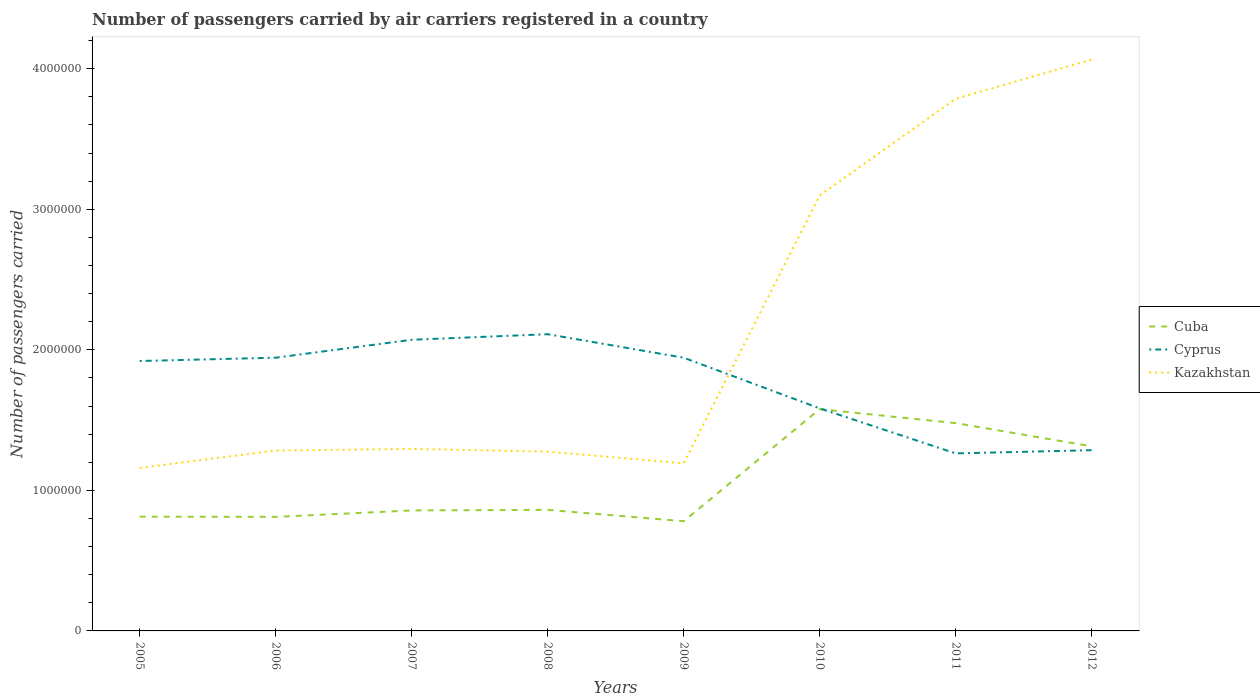How many different coloured lines are there?
Give a very brief answer. 3. Is the number of lines equal to the number of legend labels?
Make the answer very short. Yes. Across all years, what is the maximum number of passengers carried by air carriers in Cyprus?
Your answer should be very brief. 1.26e+06. What is the total number of passengers carried by air carriers in Kazakhstan in the graph?
Provide a short and direct response. -2.78e+05. What is the difference between the highest and the second highest number of passengers carried by air carriers in Kazakhstan?
Your answer should be very brief. 2.90e+06. What is the difference between the highest and the lowest number of passengers carried by air carriers in Cyprus?
Give a very brief answer. 5. Is the number of passengers carried by air carriers in Cuba strictly greater than the number of passengers carried by air carriers in Cyprus over the years?
Keep it short and to the point. No. How many lines are there?
Offer a very short reply. 3. Does the graph contain any zero values?
Offer a very short reply. No. Does the graph contain grids?
Provide a succinct answer. No. How are the legend labels stacked?
Your answer should be compact. Vertical. What is the title of the graph?
Offer a terse response. Number of passengers carried by air carriers registered in a country. Does "Greece" appear as one of the legend labels in the graph?
Your answer should be compact. No. What is the label or title of the X-axis?
Provide a short and direct response. Years. What is the label or title of the Y-axis?
Provide a succinct answer. Number of passengers carried. What is the Number of passengers carried of Cuba in 2005?
Keep it short and to the point. 8.13e+05. What is the Number of passengers carried of Cyprus in 2005?
Provide a succinct answer. 1.92e+06. What is the Number of passengers carried of Kazakhstan in 2005?
Make the answer very short. 1.16e+06. What is the Number of passengers carried of Cuba in 2006?
Offer a terse response. 8.12e+05. What is the Number of passengers carried of Cyprus in 2006?
Provide a succinct answer. 1.94e+06. What is the Number of passengers carried of Kazakhstan in 2006?
Ensure brevity in your answer.  1.28e+06. What is the Number of passengers carried in Cuba in 2007?
Ensure brevity in your answer.  8.57e+05. What is the Number of passengers carried in Cyprus in 2007?
Offer a very short reply. 2.07e+06. What is the Number of passengers carried of Kazakhstan in 2007?
Your response must be concise. 1.30e+06. What is the Number of passengers carried in Cuba in 2008?
Give a very brief answer. 8.61e+05. What is the Number of passengers carried in Cyprus in 2008?
Provide a short and direct response. 2.11e+06. What is the Number of passengers carried in Kazakhstan in 2008?
Your answer should be compact. 1.28e+06. What is the Number of passengers carried of Cuba in 2009?
Offer a very short reply. 7.80e+05. What is the Number of passengers carried in Cyprus in 2009?
Give a very brief answer. 1.94e+06. What is the Number of passengers carried of Kazakhstan in 2009?
Keep it short and to the point. 1.19e+06. What is the Number of passengers carried of Cuba in 2010?
Your answer should be very brief. 1.58e+06. What is the Number of passengers carried of Cyprus in 2010?
Offer a very short reply. 1.58e+06. What is the Number of passengers carried of Kazakhstan in 2010?
Make the answer very short. 3.10e+06. What is the Number of passengers carried of Cuba in 2011?
Make the answer very short. 1.48e+06. What is the Number of passengers carried of Cyprus in 2011?
Ensure brevity in your answer.  1.26e+06. What is the Number of passengers carried of Kazakhstan in 2011?
Make the answer very short. 3.79e+06. What is the Number of passengers carried of Cuba in 2012?
Your answer should be very brief. 1.31e+06. What is the Number of passengers carried in Cyprus in 2012?
Make the answer very short. 1.29e+06. What is the Number of passengers carried in Kazakhstan in 2012?
Your response must be concise. 4.06e+06. Across all years, what is the maximum Number of passengers carried in Cuba?
Give a very brief answer. 1.58e+06. Across all years, what is the maximum Number of passengers carried in Cyprus?
Keep it short and to the point. 2.11e+06. Across all years, what is the maximum Number of passengers carried in Kazakhstan?
Provide a short and direct response. 4.06e+06. Across all years, what is the minimum Number of passengers carried of Cuba?
Offer a terse response. 7.80e+05. Across all years, what is the minimum Number of passengers carried in Cyprus?
Offer a terse response. 1.26e+06. Across all years, what is the minimum Number of passengers carried in Kazakhstan?
Your answer should be compact. 1.16e+06. What is the total Number of passengers carried of Cuba in the graph?
Ensure brevity in your answer.  8.49e+06. What is the total Number of passengers carried in Cyprus in the graph?
Provide a short and direct response. 1.41e+07. What is the total Number of passengers carried in Kazakhstan in the graph?
Give a very brief answer. 1.72e+07. What is the difference between the Number of passengers carried of Cuba in 2005 and that in 2006?
Offer a terse response. 1222. What is the difference between the Number of passengers carried of Cyprus in 2005 and that in 2006?
Your response must be concise. -2.36e+04. What is the difference between the Number of passengers carried in Kazakhstan in 2005 and that in 2006?
Give a very brief answer. -1.23e+05. What is the difference between the Number of passengers carried of Cuba in 2005 and that in 2007?
Your response must be concise. -4.44e+04. What is the difference between the Number of passengers carried of Cyprus in 2005 and that in 2007?
Provide a succinct answer. -1.51e+05. What is the difference between the Number of passengers carried of Kazakhstan in 2005 and that in 2007?
Offer a terse response. -1.35e+05. What is the difference between the Number of passengers carried of Cuba in 2005 and that in 2008?
Provide a succinct answer. -4.86e+04. What is the difference between the Number of passengers carried in Cyprus in 2005 and that in 2008?
Your answer should be very brief. -1.91e+05. What is the difference between the Number of passengers carried in Kazakhstan in 2005 and that in 2008?
Give a very brief answer. -1.15e+05. What is the difference between the Number of passengers carried in Cuba in 2005 and that in 2009?
Make the answer very short. 3.23e+04. What is the difference between the Number of passengers carried in Cyprus in 2005 and that in 2009?
Provide a short and direct response. -2.34e+04. What is the difference between the Number of passengers carried in Kazakhstan in 2005 and that in 2009?
Provide a short and direct response. -3.24e+04. What is the difference between the Number of passengers carried of Cuba in 2005 and that in 2010?
Offer a terse response. -7.65e+05. What is the difference between the Number of passengers carried of Cyprus in 2005 and that in 2010?
Your answer should be very brief. 3.37e+05. What is the difference between the Number of passengers carried in Kazakhstan in 2005 and that in 2010?
Your response must be concise. -1.94e+06. What is the difference between the Number of passengers carried in Cuba in 2005 and that in 2011?
Give a very brief answer. -6.66e+05. What is the difference between the Number of passengers carried in Cyprus in 2005 and that in 2011?
Your response must be concise. 6.57e+05. What is the difference between the Number of passengers carried in Kazakhstan in 2005 and that in 2011?
Your answer should be compact. -2.63e+06. What is the difference between the Number of passengers carried in Cuba in 2005 and that in 2012?
Your response must be concise. -5.01e+05. What is the difference between the Number of passengers carried in Cyprus in 2005 and that in 2012?
Your answer should be very brief. 6.35e+05. What is the difference between the Number of passengers carried of Kazakhstan in 2005 and that in 2012?
Make the answer very short. -2.90e+06. What is the difference between the Number of passengers carried in Cuba in 2006 and that in 2007?
Give a very brief answer. -4.57e+04. What is the difference between the Number of passengers carried in Cyprus in 2006 and that in 2007?
Ensure brevity in your answer.  -1.28e+05. What is the difference between the Number of passengers carried in Kazakhstan in 2006 and that in 2007?
Make the answer very short. -1.18e+04. What is the difference between the Number of passengers carried in Cuba in 2006 and that in 2008?
Your answer should be compact. -4.98e+04. What is the difference between the Number of passengers carried of Cyprus in 2006 and that in 2008?
Keep it short and to the point. -1.67e+05. What is the difference between the Number of passengers carried in Kazakhstan in 2006 and that in 2008?
Provide a succinct answer. 7626. What is the difference between the Number of passengers carried of Cuba in 2006 and that in 2009?
Make the answer very short. 3.11e+04. What is the difference between the Number of passengers carried in Cyprus in 2006 and that in 2009?
Your answer should be compact. 189. What is the difference between the Number of passengers carried of Kazakhstan in 2006 and that in 2009?
Your answer should be compact. 9.05e+04. What is the difference between the Number of passengers carried in Cuba in 2006 and that in 2010?
Make the answer very short. -7.66e+05. What is the difference between the Number of passengers carried in Cyprus in 2006 and that in 2010?
Offer a terse response. 3.61e+05. What is the difference between the Number of passengers carried of Kazakhstan in 2006 and that in 2010?
Provide a succinct answer. -1.82e+06. What is the difference between the Number of passengers carried of Cuba in 2006 and that in 2011?
Keep it short and to the point. -6.67e+05. What is the difference between the Number of passengers carried in Cyprus in 2006 and that in 2011?
Your answer should be very brief. 6.81e+05. What is the difference between the Number of passengers carried of Kazakhstan in 2006 and that in 2011?
Keep it short and to the point. -2.50e+06. What is the difference between the Number of passengers carried of Cuba in 2006 and that in 2012?
Offer a very short reply. -5.02e+05. What is the difference between the Number of passengers carried in Cyprus in 2006 and that in 2012?
Your answer should be compact. 6.58e+05. What is the difference between the Number of passengers carried in Kazakhstan in 2006 and that in 2012?
Ensure brevity in your answer.  -2.78e+06. What is the difference between the Number of passengers carried in Cuba in 2007 and that in 2008?
Keep it short and to the point. -4139. What is the difference between the Number of passengers carried of Cyprus in 2007 and that in 2008?
Give a very brief answer. -3.96e+04. What is the difference between the Number of passengers carried in Kazakhstan in 2007 and that in 2008?
Offer a terse response. 1.94e+04. What is the difference between the Number of passengers carried in Cuba in 2007 and that in 2009?
Your answer should be very brief. 7.67e+04. What is the difference between the Number of passengers carried in Cyprus in 2007 and that in 2009?
Make the answer very short. 1.28e+05. What is the difference between the Number of passengers carried in Kazakhstan in 2007 and that in 2009?
Give a very brief answer. 1.02e+05. What is the difference between the Number of passengers carried in Cuba in 2007 and that in 2010?
Provide a succinct answer. -7.21e+05. What is the difference between the Number of passengers carried of Cyprus in 2007 and that in 2010?
Keep it short and to the point. 4.88e+05. What is the difference between the Number of passengers carried in Kazakhstan in 2007 and that in 2010?
Offer a terse response. -1.80e+06. What is the difference between the Number of passengers carried in Cuba in 2007 and that in 2011?
Provide a short and direct response. -6.21e+05. What is the difference between the Number of passengers carried of Cyprus in 2007 and that in 2011?
Provide a short and direct response. 8.09e+05. What is the difference between the Number of passengers carried in Kazakhstan in 2007 and that in 2011?
Your answer should be compact. -2.49e+06. What is the difference between the Number of passengers carried in Cuba in 2007 and that in 2012?
Your response must be concise. -4.56e+05. What is the difference between the Number of passengers carried in Cyprus in 2007 and that in 2012?
Give a very brief answer. 7.86e+05. What is the difference between the Number of passengers carried of Kazakhstan in 2007 and that in 2012?
Your response must be concise. -2.77e+06. What is the difference between the Number of passengers carried of Cuba in 2008 and that in 2009?
Give a very brief answer. 8.09e+04. What is the difference between the Number of passengers carried of Cyprus in 2008 and that in 2009?
Your answer should be compact. 1.67e+05. What is the difference between the Number of passengers carried of Kazakhstan in 2008 and that in 2009?
Provide a short and direct response. 8.29e+04. What is the difference between the Number of passengers carried of Cuba in 2008 and that in 2010?
Make the answer very short. -7.17e+05. What is the difference between the Number of passengers carried of Cyprus in 2008 and that in 2010?
Your answer should be very brief. 5.28e+05. What is the difference between the Number of passengers carried of Kazakhstan in 2008 and that in 2010?
Keep it short and to the point. -1.82e+06. What is the difference between the Number of passengers carried in Cuba in 2008 and that in 2011?
Keep it short and to the point. -6.17e+05. What is the difference between the Number of passengers carried in Cyprus in 2008 and that in 2011?
Provide a short and direct response. 8.48e+05. What is the difference between the Number of passengers carried of Kazakhstan in 2008 and that in 2011?
Your answer should be very brief. -2.51e+06. What is the difference between the Number of passengers carried of Cuba in 2008 and that in 2012?
Offer a very short reply. -4.52e+05. What is the difference between the Number of passengers carried in Cyprus in 2008 and that in 2012?
Make the answer very short. 8.25e+05. What is the difference between the Number of passengers carried in Kazakhstan in 2008 and that in 2012?
Give a very brief answer. -2.79e+06. What is the difference between the Number of passengers carried of Cuba in 2009 and that in 2010?
Your response must be concise. -7.98e+05. What is the difference between the Number of passengers carried in Cyprus in 2009 and that in 2010?
Your answer should be very brief. 3.60e+05. What is the difference between the Number of passengers carried of Kazakhstan in 2009 and that in 2010?
Keep it short and to the point. -1.91e+06. What is the difference between the Number of passengers carried in Cuba in 2009 and that in 2011?
Your answer should be very brief. -6.98e+05. What is the difference between the Number of passengers carried of Cyprus in 2009 and that in 2011?
Your answer should be compact. 6.81e+05. What is the difference between the Number of passengers carried in Kazakhstan in 2009 and that in 2011?
Provide a succinct answer. -2.59e+06. What is the difference between the Number of passengers carried of Cuba in 2009 and that in 2012?
Ensure brevity in your answer.  -5.33e+05. What is the difference between the Number of passengers carried of Cyprus in 2009 and that in 2012?
Make the answer very short. 6.58e+05. What is the difference between the Number of passengers carried in Kazakhstan in 2009 and that in 2012?
Offer a very short reply. -2.87e+06. What is the difference between the Number of passengers carried of Cuba in 2010 and that in 2011?
Make the answer very short. 9.94e+04. What is the difference between the Number of passengers carried in Cyprus in 2010 and that in 2011?
Offer a very short reply. 3.21e+05. What is the difference between the Number of passengers carried in Kazakhstan in 2010 and that in 2011?
Your answer should be very brief. -6.88e+05. What is the difference between the Number of passengers carried in Cuba in 2010 and that in 2012?
Make the answer very short. 2.65e+05. What is the difference between the Number of passengers carried in Cyprus in 2010 and that in 2012?
Provide a succinct answer. 2.98e+05. What is the difference between the Number of passengers carried in Kazakhstan in 2010 and that in 2012?
Make the answer very short. -9.66e+05. What is the difference between the Number of passengers carried in Cuba in 2011 and that in 2012?
Provide a short and direct response. 1.65e+05. What is the difference between the Number of passengers carried of Cyprus in 2011 and that in 2012?
Offer a terse response. -2.29e+04. What is the difference between the Number of passengers carried of Kazakhstan in 2011 and that in 2012?
Ensure brevity in your answer.  -2.78e+05. What is the difference between the Number of passengers carried in Cuba in 2005 and the Number of passengers carried in Cyprus in 2006?
Your answer should be compact. -1.13e+06. What is the difference between the Number of passengers carried in Cuba in 2005 and the Number of passengers carried in Kazakhstan in 2006?
Provide a short and direct response. -4.70e+05. What is the difference between the Number of passengers carried of Cyprus in 2005 and the Number of passengers carried of Kazakhstan in 2006?
Your answer should be very brief. 6.37e+05. What is the difference between the Number of passengers carried in Cuba in 2005 and the Number of passengers carried in Cyprus in 2007?
Your response must be concise. -1.26e+06. What is the difference between the Number of passengers carried of Cuba in 2005 and the Number of passengers carried of Kazakhstan in 2007?
Provide a short and direct response. -4.82e+05. What is the difference between the Number of passengers carried in Cyprus in 2005 and the Number of passengers carried in Kazakhstan in 2007?
Keep it short and to the point. 6.25e+05. What is the difference between the Number of passengers carried in Cuba in 2005 and the Number of passengers carried in Cyprus in 2008?
Keep it short and to the point. -1.30e+06. What is the difference between the Number of passengers carried of Cuba in 2005 and the Number of passengers carried of Kazakhstan in 2008?
Ensure brevity in your answer.  -4.63e+05. What is the difference between the Number of passengers carried of Cyprus in 2005 and the Number of passengers carried of Kazakhstan in 2008?
Provide a short and direct response. 6.45e+05. What is the difference between the Number of passengers carried of Cuba in 2005 and the Number of passengers carried of Cyprus in 2009?
Offer a terse response. -1.13e+06. What is the difference between the Number of passengers carried in Cuba in 2005 and the Number of passengers carried in Kazakhstan in 2009?
Your response must be concise. -3.80e+05. What is the difference between the Number of passengers carried of Cyprus in 2005 and the Number of passengers carried of Kazakhstan in 2009?
Your answer should be very brief. 7.28e+05. What is the difference between the Number of passengers carried of Cuba in 2005 and the Number of passengers carried of Cyprus in 2010?
Offer a terse response. -7.71e+05. What is the difference between the Number of passengers carried in Cuba in 2005 and the Number of passengers carried in Kazakhstan in 2010?
Offer a terse response. -2.29e+06. What is the difference between the Number of passengers carried of Cyprus in 2005 and the Number of passengers carried of Kazakhstan in 2010?
Your answer should be very brief. -1.18e+06. What is the difference between the Number of passengers carried in Cuba in 2005 and the Number of passengers carried in Cyprus in 2011?
Provide a succinct answer. -4.50e+05. What is the difference between the Number of passengers carried in Cuba in 2005 and the Number of passengers carried in Kazakhstan in 2011?
Ensure brevity in your answer.  -2.97e+06. What is the difference between the Number of passengers carried in Cyprus in 2005 and the Number of passengers carried in Kazakhstan in 2011?
Offer a terse response. -1.87e+06. What is the difference between the Number of passengers carried in Cuba in 2005 and the Number of passengers carried in Cyprus in 2012?
Make the answer very short. -4.73e+05. What is the difference between the Number of passengers carried of Cuba in 2005 and the Number of passengers carried of Kazakhstan in 2012?
Provide a succinct answer. -3.25e+06. What is the difference between the Number of passengers carried of Cyprus in 2005 and the Number of passengers carried of Kazakhstan in 2012?
Your response must be concise. -2.14e+06. What is the difference between the Number of passengers carried in Cuba in 2006 and the Number of passengers carried in Cyprus in 2007?
Keep it short and to the point. -1.26e+06. What is the difference between the Number of passengers carried of Cuba in 2006 and the Number of passengers carried of Kazakhstan in 2007?
Your answer should be compact. -4.83e+05. What is the difference between the Number of passengers carried in Cyprus in 2006 and the Number of passengers carried in Kazakhstan in 2007?
Give a very brief answer. 6.49e+05. What is the difference between the Number of passengers carried in Cuba in 2006 and the Number of passengers carried in Cyprus in 2008?
Your answer should be very brief. -1.30e+06. What is the difference between the Number of passengers carried of Cuba in 2006 and the Number of passengers carried of Kazakhstan in 2008?
Keep it short and to the point. -4.64e+05. What is the difference between the Number of passengers carried of Cyprus in 2006 and the Number of passengers carried of Kazakhstan in 2008?
Your answer should be very brief. 6.69e+05. What is the difference between the Number of passengers carried in Cuba in 2006 and the Number of passengers carried in Cyprus in 2009?
Make the answer very short. -1.13e+06. What is the difference between the Number of passengers carried in Cuba in 2006 and the Number of passengers carried in Kazakhstan in 2009?
Your answer should be very brief. -3.81e+05. What is the difference between the Number of passengers carried of Cyprus in 2006 and the Number of passengers carried of Kazakhstan in 2009?
Your answer should be compact. 7.51e+05. What is the difference between the Number of passengers carried in Cuba in 2006 and the Number of passengers carried in Cyprus in 2010?
Provide a succinct answer. -7.72e+05. What is the difference between the Number of passengers carried of Cuba in 2006 and the Number of passengers carried of Kazakhstan in 2010?
Offer a terse response. -2.29e+06. What is the difference between the Number of passengers carried of Cyprus in 2006 and the Number of passengers carried of Kazakhstan in 2010?
Keep it short and to the point. -1.15e+06. What is the difference between the Number of passengers carried in Cuba in 2006 and the Number of passengers carried in Cyprus in 2011?
Provide a succinct answer. -4.52e+05. What is the difference between the Number of passengers carried of Cuba in 2006 and the Number of passengers carried of Kazakhstan in 2011?
Give a very brief answer. -2.97e+06. What is the difference between the Number of passengers carried of Cyprus in 2006 and the Number of passengers carried of Kazakhstan in 2011?
Give a very brief answer. -1.84e+06. What is the difference between the Number of passengers carried of Cuba in 2006 and the Number of passengers carried of Cyprus in 2012?
Ensure brevity in your answer.  -4.74e+05. What is the difference between the Number of passengers carried of Cuba in 2006 and the Number of passengers carried of Kazakhstan in 2012?
Offer a terse response. -3.25e+06. What is the difference between the Number of passengers carried in Cyprus in 2006 and the Number of passengers carried in Kazakhstan in 2012?
Give a very brief answer. -2.12e+06. What is the difference between the Number of passengers carried of Cuba in 2007 and the Number of passengers carried of Cyprus in 2008?
Offer a very short reply. -1.25e+06. What is the difference between the Number of passengers carried in Cuba in 2007 and the Number of passengers carried in Kazakhstan in 2008?
Your answer should be very brief. -4.18e+05. What is the difference between the Number of passengers carried in Cyprus in 2007 and the Number of passengers carried in Kazakhstan in 2008?
Make the answer very short. 7.96e+05. What is the difference between the Number of passengers carried of Cuba in 2007 and the Number of passengers carried of Cyprus in 2009?
Your answer should be compact. -1.09e+06. What is the difference between the Number of passengers carried in Cuba in 2007 and the Number of passengers carried in Kazakhstan in 2009?
Your response must be concise. -3.36e+05. What is the difference between the Number of passengers carried of Cyprus in 2007 and the Number of passengers carried of Kazakhstan in 2009?
Make the answer very short. 8.79e+05. What is the difference between the Number of passengers carried in Cuba in 2007 and the Number of passengers carried in Cyprus in 2010?
Your response must be concise. -7.26e+05. What is the difference between the Number of passengers carried of Cuba in 2007 and the Number of passengers carried of Kazakhstan in 2010?
Provide a short and direct response. -2.24e+06. What is the difference between the Number of passengers carried of Cyprus in 2007 and the Number of passengers carried of Kazakhstan in 2010?
Give a very brief answer. -1.03e+06. What is the difference between the Number of passengers carried of Cuba in 2007 and the Number of passengers carried of Cyprus in 2011?
Give a very brief answer. -4.06e+05. What is the difference between the Number of passengers carried in Cuba in 2007 and the Number of passengers carried in Kazakhstan in 2011?
Provide a short and direct response. -2.93e+06. What is the difference between the Number of passengers carried in Cyprus in 2007 and the Number of passengers carried in Kazakhstan in 2011?
Give a very brief answer. -1.71e+06. What is the difference between the Number of passengers carried in Cuba in 2007 and the Number of passengers carried in Cyprus in 2012?
Your answer should be very brief. -4.29e+05. What is the difference between the Number of passengers carried in Cuba in 2007 and the Number of passengers carried in Kazakhstan in 2012?
Provide a succinct answer. -3.21e+06. What is the difference between the Number of passengers carried of Cyprus in 2007 and the Number of passengers carried of Kazakhstan in 2012?
Provide a succinct answer. -1.99e+06. What is the difference between the Number of passengers carried of Cuba in 2008 and the Number of passengers carried of Cyprus in 2009?
Offer a terse response. -1.08e+06. What is the difference between the Number of passengers carried of Cuba in 2008 and the Number of passengers carried of Kazakhstan in 2009?
Your answer should be very brief. -3.31e+05. What is the difference between the Number of passengers carried of Cyprus in 2008 and the Number of passengers carried of Kazakhstan in 2009?
Your answer should be compact. 9.18e+05. What is the difference between the Number of passengers carried of Cuba in 2008 and the Number of passengers carried of Cyprus in 2010?
Your answer should be very brief. -7.22e+05. What is the difference between the Number of passengers carried of Cuba in 2008 and the Number of passengers carried of Kazakhstan in 2010?
Your response must be concise. -2.24e+06. What is the difference between the Number of passengers carried in Cyprus in 2008 and the Number of passengers carried in Kazakhstan in 2010?
Keep it short and to the point. -9.87e+05. What is the difference between the Number of passengers carried of Cuba in 2008 and the Number of passengers carried of Cyprus in 2011?
Make the answer very short. -4.02e+05. What is the difference between the Number of passengers carried in Cuba in 2008 and the Number of passengers carried in Kazakhstan in 2011?
Make the answer very short. -2.93e+06. What is the difference between the Number of passengers carried of Cyprus in 2008 and the Number of passengers carried of Kazakhstan in 2011?
Your answer should be compact. -1.68e+06. What is the difference between the Number of passengers carried of Cuba in 2008 and the Number of passengers carried of Cyprus in 2012?
Your answer should be very brief. -4.25e+05. What is the difference between the Number of passengers carried in Cuba in 2008 and the Number of passengers carried in Kazakhstan in 2012?
Your response must be concise. -3.20e+06. What is the difference between the Number of passengers carried of Cyprus in 2008 and the Number of passengers carried of Kazakhstan in 2012?
Provide a short and direct response. -1.95e+06. What is the difference between the Number of passengers carried of Cuba in 2009 and the Number of passengers carried of Cyprus in 2010?
Your response must be concise. -8.03e+05. What is the difference between the Number of passengers carried in Cuba in 2009 and the Number of passengers carried in Kazakhstan in 2010?
Ensure brevity in your answer.  -2.32e+06. What is the difference between the Number of passengers carried in Cyprus in 2009 and the Number of passengers carried in Kazakhstan in 2010?
Provide a succinct answer. -1.15e+06. What is the difference between the Number of passengers carried of Cuba in 2009 and the Number of passengers carried of Cyprus in 2011?
Make the answer very short. -4.83e+05. What is the difference between the Number of passengers carried in Cuba in 2009 and the Number of passengers carried in Kazakhstan in 2011?
Offer a very short reply. -3.01e+06. What is the difference between the Number of passengers carried of Cyprus in 2009 and the Number of passengers carried of Kazakhstan in 2011?
Give a very brief answer. -1.84e+06. What is the difference between the Number of passengers carried of Cuba in 2009 and the Number of passengers carried of Cyprus in 2012?
Your answer should be very brief. -5.05e+05. What is the difference between the Number of passengers carried of Cuba in 2009 and the Number of passengers carried of Kazakhstan in 2012?
Your answer should be compact. -3.28e+06. What is the difference between the Number of passengers carried of Cyprus in 2009 and the Number of passengers carried of Kazakhstan in 2012?
Give a very brief answer. -2.12e+06. What is the difference between the Number of passengers carried in Cuba in 2010 and the Number of passengers carried in Cyprus in 2011?
Make the answer very short. 3.15e+05. What is the difference between the Number of passengers carried of Cuba in 2010 and the Number of passengers carried of Kazakhstan in 2011?
Provide a short and direct response. -2.21e+06. What is the difference between the Number of passengers carried in Cyprus in 2010 and the Number of passengers carried in Kazakhstan in 2011?
Provide a short and direct response. -2.20e+06. What is the difference between the Number of passengers carried of Cuba in 2010 and the Number of passengers carried of Cyprus in 2012?
Offer a terse response. 2.92e+05. What is the difference between the Number of passengers carried of Cuba in 2010 and the Number of passengers carried of Kazakhstan in 2012?
Your response must be concise. -2.49e+06. What is the difference between the Number of passengers carried of Cyprus in 2010 and the Number of passengers carried of Kazakhstan in 2012?
Offer a very short reply. -2.48e+06. What is the difference between the Number of passengers carried in Cuba in 2011 and the Number of passengers carried in Cyprus in 2012?
Keep it short and to the point. 1.93e+05. What is the difference between the Number of passengers carried of Cuba in 2011 and the Number of passengers carried of Kazakhstan in 2012?
Provide a short and direct response. -2.59e+06. What is the difference between the Number of passengers carried in Cyprus in 2011 and the Number of passengers carried in Kazakhstan in 2012?
Offer a very short reply. -2.80e+06. What is the average Number of passengers carried of Cuba per year?
Offer a very short reply. 1.06e+06. What is the average Number of passengers carried in Cyprus per year?
Offer a very short reply. 1.77e+06. What is the average Number of passengers carried of Kazakhstan per year?
Your answer should be compact. 2.14e+06. In the year 2005, what is the difference between the Number of passengers carried of Cuba and Number of passengers carried of Cyprus?
Your answer should be very brief. -1.11e+06. In the year 2005, what is the difference between the Number of passengers carried in Cuba and Number of passengers carried in Kazakhstan?
Keep it short and to the point. -3.48e+05. In the year 2005, what is the difference between the Number of passengers carried of Cyprus and Number of passengers carried of Kazakhstan?
Ensure brevity in your answer.  7.60e+05. In the year 2006, what is the difference between the Number of passengers carried of Cuba and Number of passengers carried of Cyprus?
Make the answer very short. -1.13e+06. In the year 2006, what is the difference between the Number of passengers carried in Cuba and Number of passengers carried in Kazakhstan?
Provide a short and direct response. -4.72e+05. In the year 2006, what is the difference between the Number of passengers carried in Cyprus and Number of passengers carried in Kazakhstan?
Offer a terse response. 6.61e+05. In the year 2007, what is the difference between the Number of passengers carried of Cuba and Number of passengers carried of Cyprus?
Your response must be concise. -1.21e+06. In the year 2007, what is the difference between the Number of passengers carried in Cuba and Number of passengers carried in Kazakhstan?
Make the answer very short. -4.38e+05. In the year 2007, what is the difference between the Number of passengers carried of Cyprus and Number of passengers carried of Kazakhstan?
Give a very brief answer. 7.77e+05. In the year 2008, what is the difference between the Number of passengers carried of Cuba and Number of passengers carried of Cyprus?
Ensure brevity in your answer.  -1.25e+06. In the year 2008, what is the difference between the Number of passengers carried in Cuba and Number of passengers carried in Kazakhstan?
Your answer should be compact. -4.14e+05. In the year 2008, what is the difference between the Number of passengers carried in Cyprus and Number of passengers carried in Kazakhstan?
Give a very brief answer. 8.36e+05. In the year 2009, what is the difference between the Number of passengers carried in Cuba and Number of passengers carried in Cyprus?
Provide a short and direct response. -1.16e+06. In the year 2009, what is the difference between the Number of passengers carried of Cuba and Number of passengers carried of Kazakhstan?
Offer a terse response. -4.12e+05. In the year 2009, what is the difference between the Number of passengers carried of Cyprus and Number of passengers carried of Kazakhstan?
Your answer should be compact. 7.51e+05. In the year 2010, what is the difference between the Number of passengers carried in Cuba and Number of passengers carried in Cyprus?
Give a very brief answer. -5615.21. In the year 2010, what is the difference between the Number of passengers carried in Cuba and Number of passengers carried in Kazakhstan?
Your response must be concise. -1.52e+06. In the year 2010, what is the difference between the Number of passengers carried of Cyprus and Number of passengers carried of Kazakhstan?
Give a very brief answer. -1.51e+06. In the year 2011, what is the difference between the Number of passengers carried in Cuba and Number of passengers carried in Cyprus?
Ensure brevity in your answer.  2.15e+05. In the year 2011, what is the difference between the Number of passengers carried of Cuba and Number of passengers carried of Kazakhstan?
Provide a short and direct response. -2.31e+06. In the year 2011, what is the difference between the Number of passengers carried of Cyprus and Number of passengers carried of Kazakhstan?
Provide a short and direct response. -2.52e+06. In the year 2012, what is the difference between the Number of passengers carried in Cuba and Number of passengers carried in Cyprus?
Give a very brief answer. 2.75e+04. In the year 2012, what is the difference between the Number of passengers carried in Cuba and Number of passengers carried in Kazakhstan?
Ensure brevity in your answer.  -2.75e+06. In the year 2012, what is the difference between the Number of passengers carried of Cyprus and Number of passengers carried of Kazakhstan?
Your answer should be very brief. -2.78e+06. What is the ratio of the Number of passengers carried in Cuba in 2005 to that in 2006?
Keep it short and to the point. 1. What is the ratio of the Number of passengers carried in Kazakhstan in 2005 to that in 2006?
Ensure brevity in your answer.  0.9. What is the ratio of the Number of passengers carried in Cuba in 2005 to that in 2007?
Keep it short and to the point. 0.95. What is the ratio of the Number of passengers carried in Cyprus in 2005 to that in 2007?
Your answer should be very brief. 0.93. What is the ratio of the Number of passengers carried in Kazakhstan in 2005 to that in 2007?
Make the answer very short. 0.9. What is the ratio of the Number of passengers carried in Cuba in 2005 to that in 2008?
Your answer should be very brief. 0.94. What is the ratio of the Number of passengers carried in Cyprus in 2005 to that in 2008?
Keep it short and to the point. 0.91. What is the ratio of the Number of passengers carried in Kazakhstan in 2005 to that in 2008?
Offer a very short reply. 0.91. What is the ratio of the Number of passengers carried in Cuba in 2005 to that in 2009?
Offer a very short reply. 1.04. What is the ratio of the Number of passengers carried of Cyprus in 2005 to that in 2009?
Provide a succinct answer. 0.99. What is the ratio of the Number of passengers carried in Kazakhstan in 2005 to that in 2009?
Offer a very short reply. 0.97. What is the ratio of the Number of passengers carried in Cuba in 2005 to that in 2010?
Your answer should be compact. 0.52. What is the ratio of the Number of passengers carried of Cyprus in 2005 to that in 2010?
Offer a very short reply. 1.21. What is the ratio of the Number of passengers carried of Kazakhstan in 2005 to that in 2010?
Keep it short and to the point. 0.37. What is the ratio of the Number of passengers carried of Cuba in 2005 to that in 2011?
Your answer should be compact. 0.55. What is the ratio of the Number of passengers carried in Cyprus in 2005 to that in 2011?
Give a very brief answer. 1.52. What is the ratio of the Number of passengers carried of Kazakhstan in 2005 to that in 2011?
Your answer should be compact. 0.31. What is the ratio of the Number of passengers carried of Cuba in 2005 to that in 2012?
Keep it short and to the point. 0.62. What is the ratio of the Number of passengers carried in Cyprus in 2005 to that in 2012?
Make the answer very short. 1.49. What is the ratio of the Number of passengers carried in Kazakhstan in 2005 to that in 2012?
Offer a very short reply. 0.29. What is the ratio of the Number of passengers carried in Cuba in 2006 to that in 2007?
Make the answer very short. 0.95. What is the ratio of the Number of passengers carried in Cyprus in 2006 to that in 2007?
Keep it short and to the point. 0.94. What is the ratio of the Number of passengers carried in Kazakhstan in 2006 to that in 2007?
Give a very brief answer. 0.99. What is the ratio of the Number of passengers carried in Cuba in 2006 to that in 2008?
Keep it short and to the point. 0.94. What is the ratio of the Number of passengers carried in Cyprus in 2006 to that in 2008?
Ensure brevity in your answer.  0.92. What is the ratio of the Number of passengers carried of Kazakhstan in 2006 to that in 2008?
Provide a succinct answer. 1.01. What is the ratio of the Number of passengers carried of Cuba in 2006 to that in 2009?
Keep it short and to the point. 1.04. What is the ratio of the Number of passengers carried in Kazakhstan in 2006 to that in 2009?
Offer a very short reply. 1.08. What is the ratio of the Number of passengers carried in Cuba in 2006 to that in 2010?
Give a very brief answer. 0.51. What is the ratio of the Number of passengers carried of Cyprus in 2006 to that in 2010?
Provide a short and direct response. 1.23. What is the ratio of the Number of passengers carried of Kazakhstan in 2006 to that in 2010?
Your answer should be compact. 0.41. What is the ratio of the Number of passengers carried of Cuba in 2006 to that in 2011?
Keep it short and to the point. 0.55. What is the ratio of the Number of passengers carried of Cyprus in 2006 to that in 2011?
Give a very brief answer. 1.54. What is the ratio of the Number of passengers carried of Kazakhstan in 2006 to that in 2011?
Give a very brief answer. 0.34. What is the ratio of the Number of passengers carried of Cuba in 2006 to that in 2012?
Give a very brief answer. 0.62. What is the ratio of the Number of passengers carried of Cyprus in 2006 to that in 2012?
Provide a short and direct response. 1.51. What is the ratio of the Number of passengers carried of Kazakhstan in 2006 to that in 2012?
Provide a short and direct response. 0.32. What is the ratio of the Number of passengers carried of Cuba in 2007 to that in 2008?
Keep it short and to the point. 1. What is the ratio of the Number of passengers carried of Cyprus in 2007 to that in 2008?
Offer a very short reply. 0.98. What is the ratio of the Number of passengers carried of Kazakhstan in 2007 to that in 2008?
Provide a succinct answer. 1.02. What is the ratio of the Number of passengers carried in Cuba in 2007 to that in 2009?
Keep it short and to the point. 1.1. What is the ratio of the Number of passengers carried of Cyprus in 2007 to that in 2009?
Your answer should be very brief. 1.07. What is the ratio of the Number of passengers carried of Kazakhstan in 2007 to that in 2009?
Provide a short and direct response. 1.09. What is the ratio of the Number of passengers carried in Cuba in 2007 to that in 2010?
Offer a terse response. 0.54. What is the ratio of the Number of passengers carried of Cyprus in 2007 to that in 2010?
Offer a terse response. 1.31. What is the ratio of the Number of passengers carried of Kazakhstan in 2007 to that in 2010?
Provide a succinct answer. 0.42. What is the ratio of the Number of passengers carried in Cuba in 2007 to that in 2011?
Offer a terse response. 0.58. What is the ratio of the Number of passengers carried of Cyprus in 2007 to that in 2011?
Ensure brevity in your answer.  1.64. What is the ratio of the Number of passengers carried of Kazakhstan in 2007 to that in 2011?
Your response must be concise. 0.34. What is the ratio of the Number of passengers carried of Cuba in 2007 to that in 2012?
Offer a terse response. 0.65. What is the ratio of the Number of passengers carried of Cyprus in 2007 to that in 2012?
Your response must be concise. 1.61. What is the ratio of the Number of passengers carried of Kazakhstan in 2007 to that in 2012?
Provide a short and direct response. 0.32. What is the ratio of the Number of passengers carried of Cuba in 2008 to that in 2009?
Your response must be concise. 1.1. What is the ratio of the Number of passengers carried in Cyprus in 2008 to that in 2009?
Your answer should be very brief. 1.09. What is the ratio of the Number of passengers carried of Kazakhstan in 2008 to that in 2009?
Ensure brevity in your answer.  1.07. What is the ratio of the Number of passengers carried in Cuba in 2008 to that in 2010?
Ensure brevity in your answer.  0.55. What is the ratio of the Number of passengers carried of Cyprus in 2008 to that in 2010?
Make the answer very short. 1.33. What is the ratio of the Number of passengers carried in Kazakhstan in 2008 to that in 2010?
Provide a succinct answer. 0.41. What is the ratio of the Number of passengers carried of Cuba in 2008 to that in 2011?
Make the answer very short. 0.58. What is the ratio of the Number of passengers carried of Cyprus in 2008 to that in 2011?
Make the answer very short. 1.67. What is the ratio of the Number of passengers carried in Kazakhstan in 2008 to that in 2011?
Your answer should be very brief. 0.34. What is the ratio of the Number of passengers carried of Cuba in 2008 to that in 2012?
Offer a terse response. 0.66. What is the ratio of the Number of passengers carried of Cyprus in 2008 to that in 2012?
Provide a succinct answer. 1.64. What is the ratio of the Number of passengers carried in Kazakhstan in 2008 to that in 2012?
Provide a succinct answer. 0.31. What is the ratio of the Number of passengers carried of Cuba in 2009 to that in 2010?
Provide a succinct answer. 0.49. What is the ratio of the Number of passengers carried of Cyprus in 2009 to that in 2010?
Provide a succinct answer. 1.23. What is the ratio of the Number of passengers carried of Kazakhstan in 2009 to that in 2010?
Provide a short and direct response. 0.39. What is the ratio of the Number of passengers carried in Cuba in 2009 to that in 2011?
Offer a very short reply. 0.53. What is the ratio of the Number of passengers carried in Cyprus in 2009 to that in 2011?
Keep it short and to the point. 1.54. What is the ratio of the Number of passengers carried in Kazakhstan in 2009 to that in 2011?
Offer a very short reply. 0.32. What is the ratio of the Number of passengers carried in Cuba in 2009 to that in 2012?
Provide a succinct answer. 0.59. What is the ratio of the Number of passengers carried in Cyprus in 2009 to that in 2012?
Provide a short and direct response. 1.51. What is the ratio of the Number of passengers carried in Kazakhstan in 2009 to that in 2012?
Give a very brief answer. 0.29. What is the ratio of the Number of passengers carried in Cuba in 2010 to that in 2011?
Offer a terse response. 1.07. What is the ratio of the Number of passengers carried of Cyprus in 2010 to that in 2011?
Offer a terse response. 1.25. What is the ratio of the Number of passengers carried of Kazakhstan in 2010 to that in 2011?
Offer a very short reply. 0.82. What is the ratio of the Number of passengers carried in Cuba in 2010 to that in 2012?
Your answer should be very brief. 1.2. What is the ratio of the Number of passengers carried of Cyprus in 2010 to that in 2012?
Your response must be concise. 1.23. What is the ratio of the Number of passengers carried of Kazakhstan in 2010 to that in 2012?
Make the answer very short. 0.76. What is the ratio of the Number of passengers carried in Cuba in 2011 to that in 2012?
Give a very brief answer. 1.13. What is the ratio of the Number of passengers carried in Cyprus in 2011 to that in 2012?
Give a very brief answer. 0.98. What is the ratio of the Number of passengers carried in Kazakhstan in 2011 to that in 2012?
Ensure brevity in your answer.  0.93. What is the difference between the highest and the second highest Number of passengers carried in Cuba?
Your response must be concise. 9.94e+04. What is the difference between the highest and the second highest Number of passengers carried of Cyprus?
Give a very brief answer. 3.96e+04. What is the difference between the highest and the second highest Number of passengers carried in Kazakhstan?
Provide a succinct answer. 2.78e+05. What is the difference between the highest and the lowest Number of passengers carried in Cuba?
Offer a terse response. 7.98e+05. What is the difference between the highest and the lowest Number of passengers carried in Cyprus?
Provide a succinct answer. 8.48e+05. What is the difference between the highest and the lowest Number of passengers carried of Kazakhstan?
Your response must be concise. 2.90e+06. 